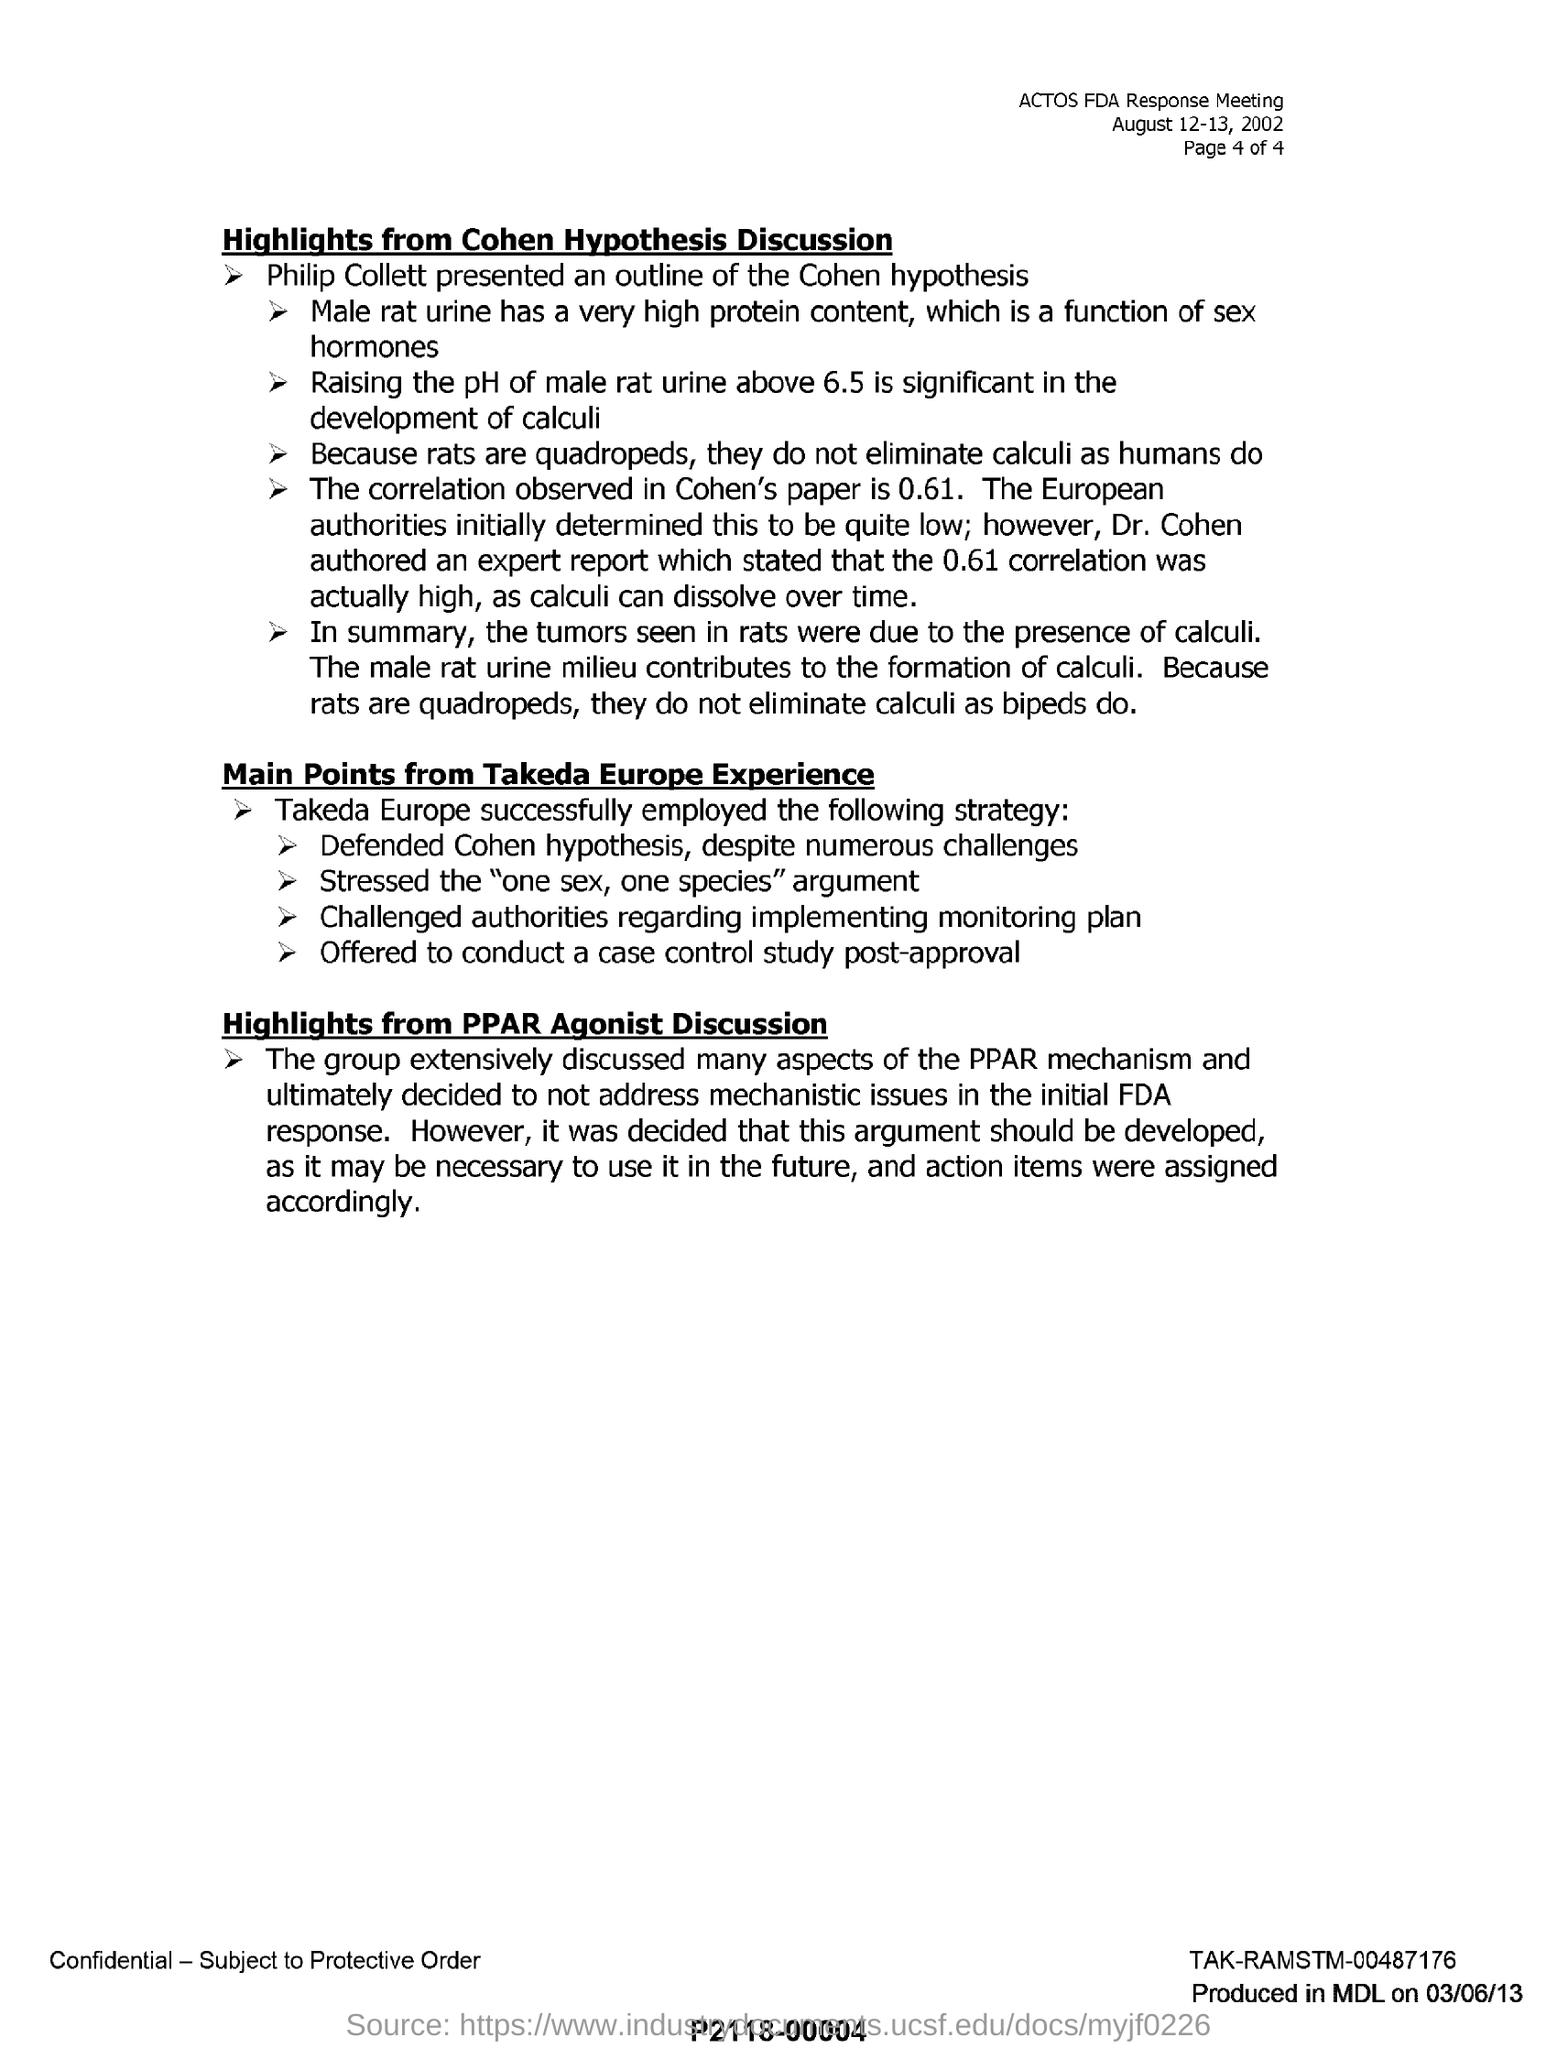Who presented an outline of the Cohen hypothesis?
Your answer should be compact. Philip Collett. What is significant in the development of calculi?
Your response must be concise. Raising the pH of male rat urine above 6.5. What is the correlation observed in cohen's paper?
Ensure brevity in your answer.  0.61. Why didn't rats eliminate calculi as humans do?
Provide a short and direct response. Because rats are quadropeds. Who challenged authorities regrading implementing monitoring plan?
Your answer should be very brief. Takeda Europe. What content is high in male rat urine?
Give a very brief answer. Protien content. 